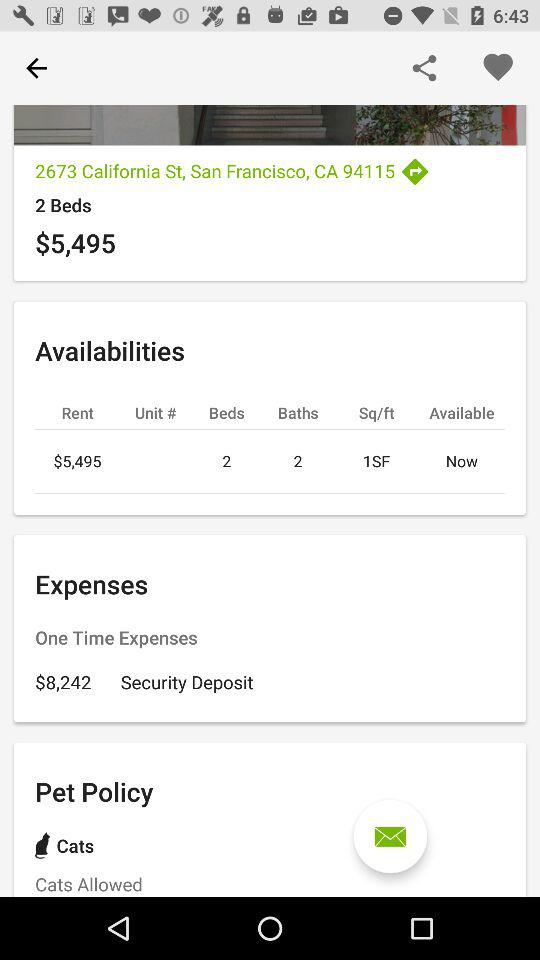How much is the security deposit? The security deposit is $8,242. 